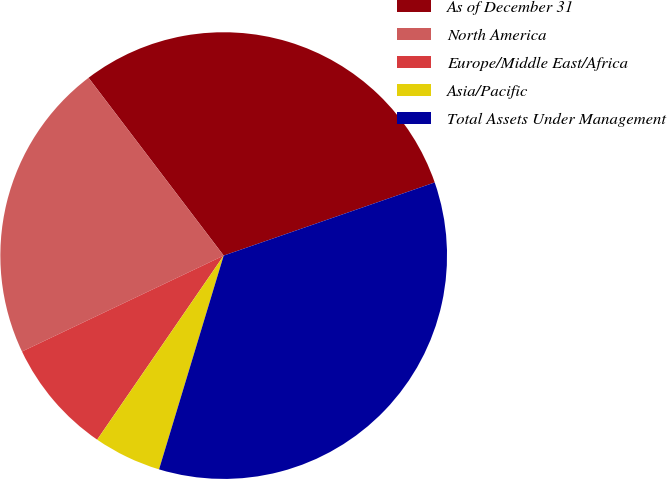<chart> <loc_0><loc_0><loc_500><loc_500><pie_chart><fcel>As of December 31<fcel>North America<fcel>Europe/Middle East/Africa<fcel>Asia/Pacific<fcel>Total Assets Under Management<nl><fcel>30.03%<fcel>21.72%<fcel>8.35%<fcel>4.91%<fcel>34.98%<nl></chart> 